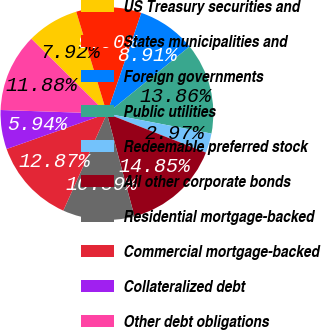Convert chart. <chart><loc_0><loc_0><loc_500><loc_500><pie_chart><fcel>US Treasury securities and<fcel>States municipalities and<fcel>Foreign governments<fcel>Public utilities<fcel>Redeemable preferred stock<fcel>All other corporate bonds<fcel>Residential mortgage-backed<fcel>Commercial mortgage-backed<fcel>Collateralized debt<fcel>Other debt obligations<nl><fcel>7.92%<fcel>9.9%<fcel>8.91%<fcel>13.86%<fcel>2.97%<fcel>14.85%<fcel>10.89%<fcel>12.87%<fcel>5.94%<fcel>11.88%<nl></chart> 